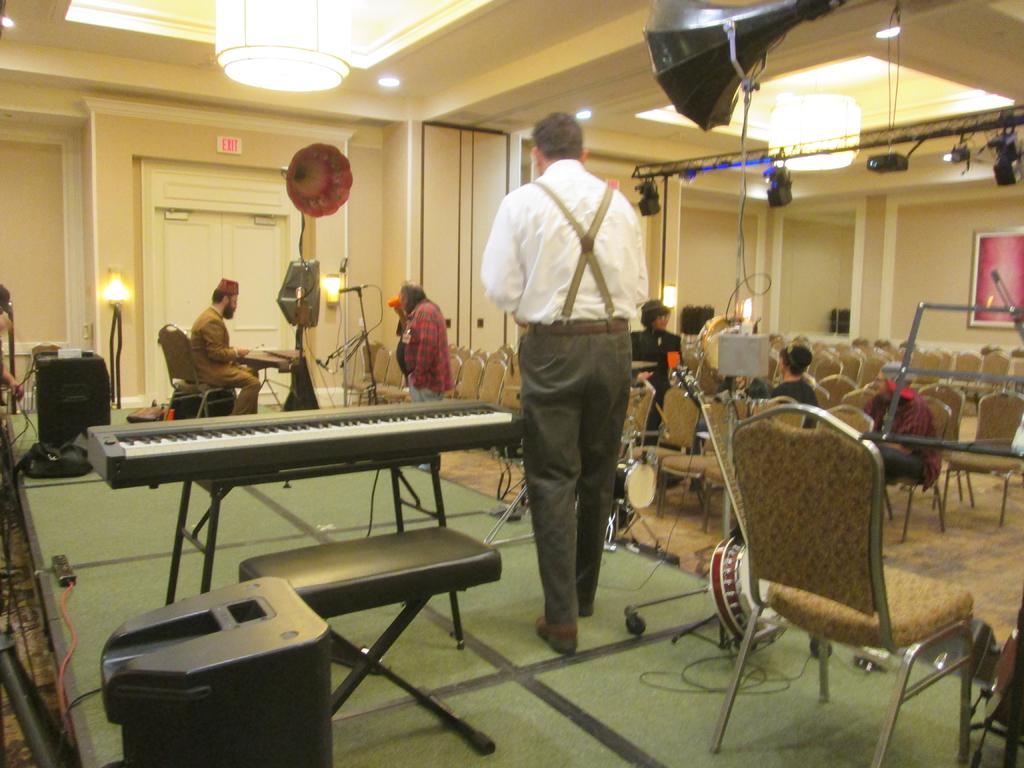Could you give a brief overview of what you see in this image? In this picture, In the left side there is a piano which is in black color and there is a table in black color, In the middle there is a man standing and there are some chairs in yellow color, In the top there is a black color object, In the background there are some people sitting on the chairs, There is a wall in yellow color in the top there is a light in yellow color. 